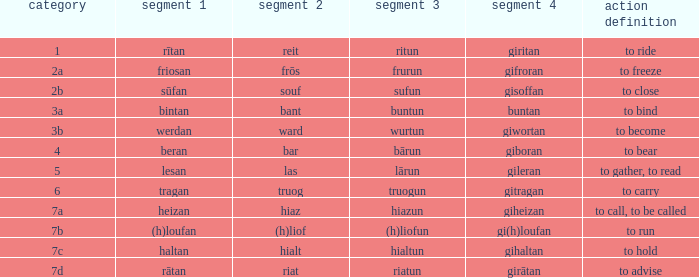What is the verb meaning of the word with part 3 "sufun"? To close. 